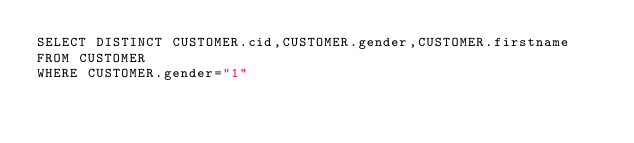Convert code to text. <code><loc_0><loc_0><loc_500><loc_500><_SQL_>SELECT DISTINCT CUSTOMER.cid,CUSTOMER.gender,CUSTOMER.firstname
FROM CUSTOMER 
WHERE CUSTOMER.gender="1"</code> 